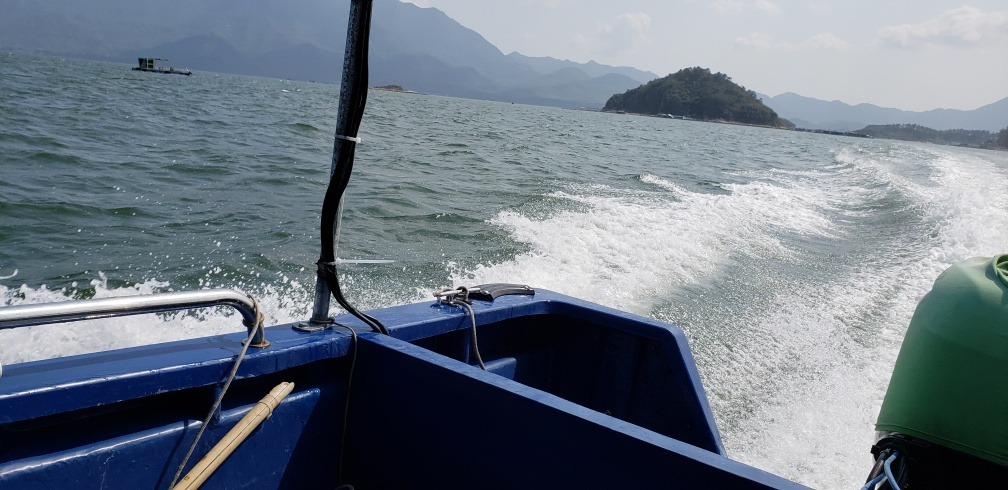What activities might be popular in this location? Given the context of the image, activities such as boating, sailing, fishing, and perhaps water sports like jet skiing could be popular in this area. The presence of distant mountains also hints at possible hiking or nature exploration opportunities near the water. 